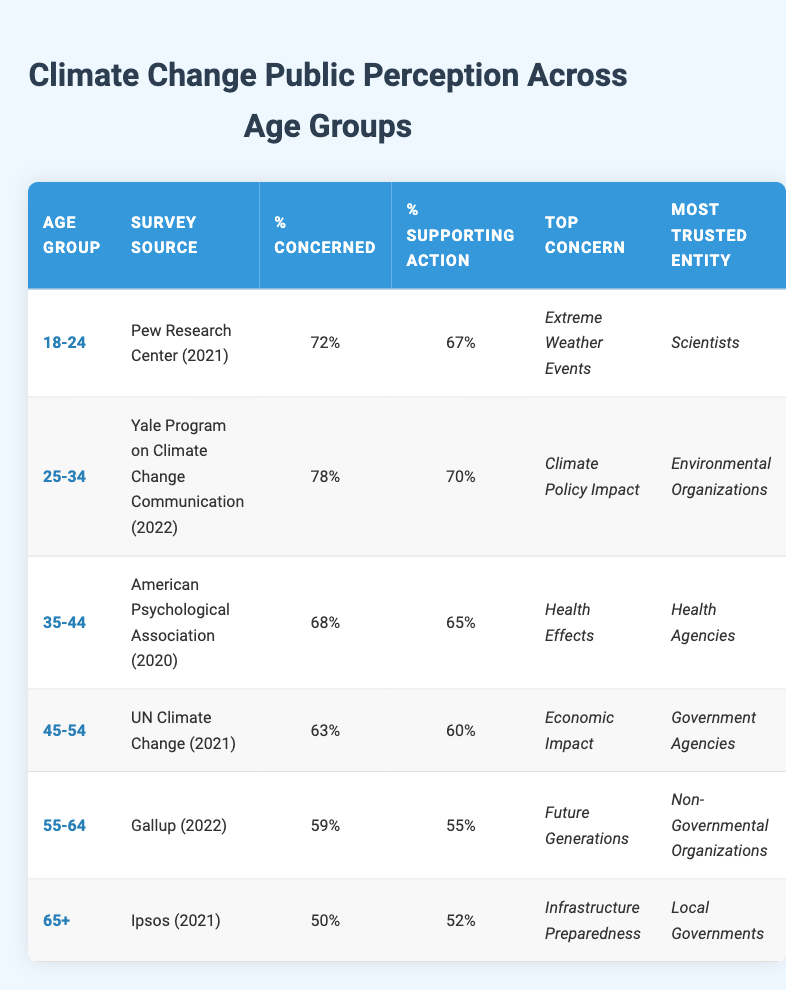What is the percentage of the 25-34 age group that is concerned about climate change? The table lists the percentage concerned for each age group. For the 25-34 age group, this value is directly stated as 78%.
Answer: 78% What is the top concern for the 45-54 age group? Looking at the column for "Top Concern," the value for the 45-54 age group is "Economic Impact."
Answer: Economic Impact Is the percentage supporting action among the 18-24 age group higher than that of the 65+ age group? The percentage supporting action for the 18-24 age group is 67%, whereas for the 65+ age group, it is 52%. Since 67% is greater than 52%, the answer is yes.
Answer: Yes What is the average percentage of concern across all age groups? The percentages concerned are: 72, 78, 68, 63, 59, and 50. Adding these values gives 72 + 78 + 68 + 63 + 59 + 50 = 390. There are 6 age groups, so the average is 390/6 = 65.
Answer: 65 Which age group has the least percentage supporting action? By scanning the "% Supporting Action" column, the 65+ age group has the lowest value at 52%.
Answer: 52% Do more people in the 35-44 age group trust Health Agencies than those in the 55-64 age group who trust Non-Governmental Organizations? The most trusted entity for the 35-44 age group is "Health Agencies," and for the 55-64 age group, it is "Non-Governmental Organizations." This question is more about perception, so we examine if more people generally trust Health Agencies than Non-Governmental Organization, which isn't quantifiable in this context. We can only answer if any lower trust level exists, which isn't directly compared here. The answer is no.
Answer: No What is the median percentage of concern across all age groups? The percentages concerned in ascending order are: 50, 59, 63, 68, 72, 78. The median (the middle value) is the average of the two middle numbers (63 and 68) which gives (63+68)/2 = 65.5.
Answer: 65.5 Which survey source reported the highest percentage of concern? By checking the "Survey Source" and corresponding "% Concerned" columns, the Yale Program on Climate Change Communication (2022) for the 25-34 age group has the highest at 78%.
Answer: Yale Program on Climate Change Communication (2022) For which age group is "Climate Policy Impact" the top concern, and what is its percentage of supporting action? The "Top Concern" for the 25-34 age group is "Climate Policy Impact." The percentage supporting action for this age group is 70%.
Answer: 70% 